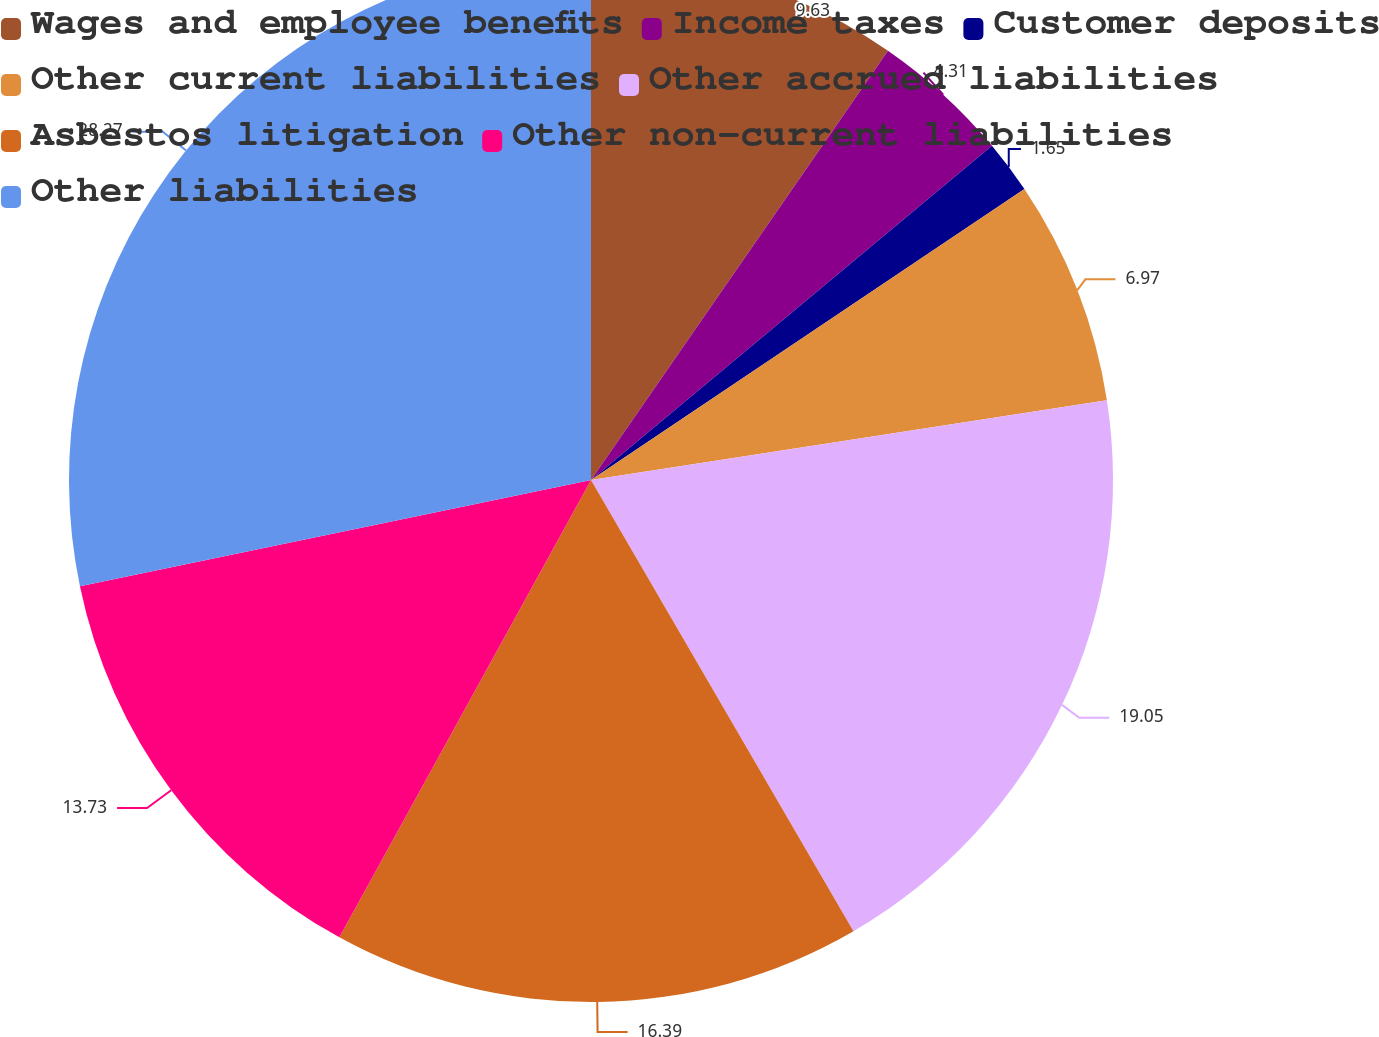Convert chart. <chart><loc_0><loc_0><loc_500><loc_500><pie_chart><fcel>Wages and employee benefits<fcel>Income taxes<fcel>Customer deposits<fcel>Other current liabilities<fcel>Other accrued liabilities<fcel>Asbestos litigation<fcel>Other non-current liabilities<fcel>Other liabilities<nl><fcel>9.63%<fcel>4.31%<fcel>1.65%<fcel>6.97%<fcel>19.05%<fcel>16.39%<fcel>13.73%<fcel>28.26%<nl></chart> 